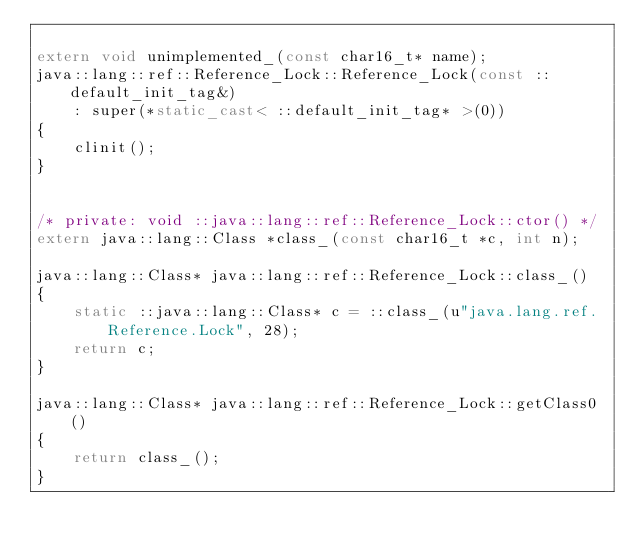<code> <loc_0><loc_0><loc_500><loc_500><_C++_>
extern void unimplemented_(const char16_t* name);
java::lang::ref::Reference_Lock::Reference_Lock(const ::default_init_tag&)
    : super(*static_cast< ::default_init_tag* >(0))
{
    clinit();
}


/* private: void ::java::lang::ref::Reference_Lock::ctor() */
extern java::lang::Class *class_(const char16_t *c, int n);

java::lang::Class* java::lang::ref::Reference_Lock::class_()
{
    static ::java::lang::Class* c = ::class_(u"java.lang.ref.Reference.Lock", 28);
    return c;
}

java::lang::Class* java::lang::ref::Reference_Lock::getClass0()
{
    return class_();
}

</code> 